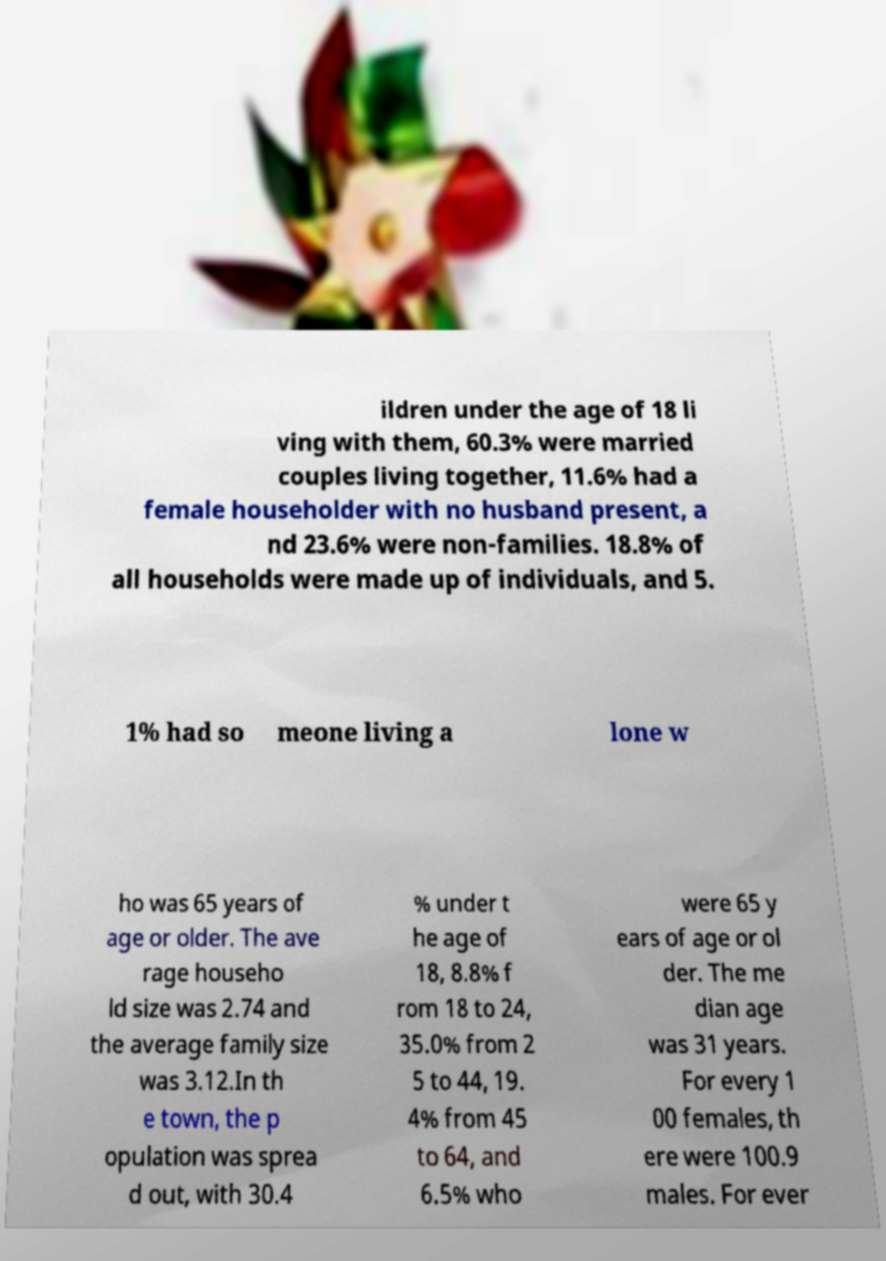Could you assist in decoding the text presented in this image and type it out clearly? ildren under the age of 18 li ving with them, 60.3% were married couples living together, 11.6% had a female householder with no husband present, a nd 23.6% were non-families. 18.8% of all households were made up of individuals, and 5. 1% had so meone living a lone w ho was 65 years of age or older. The ave rage househo ld size was 2.74 and the average family size was 3.12.In th e town, the p opulation was sprea d out, with 30.4 % under t he age of 18, 8.8% f rom 18 to 24, 35.0% from 2 5 to 44, 19. 4% from 45 to 64, and 6.5% who were 65 y ears of age or ol der. The me dian age was 31 years. For every 1 00 females, th ere were 100.9 males. For ever 